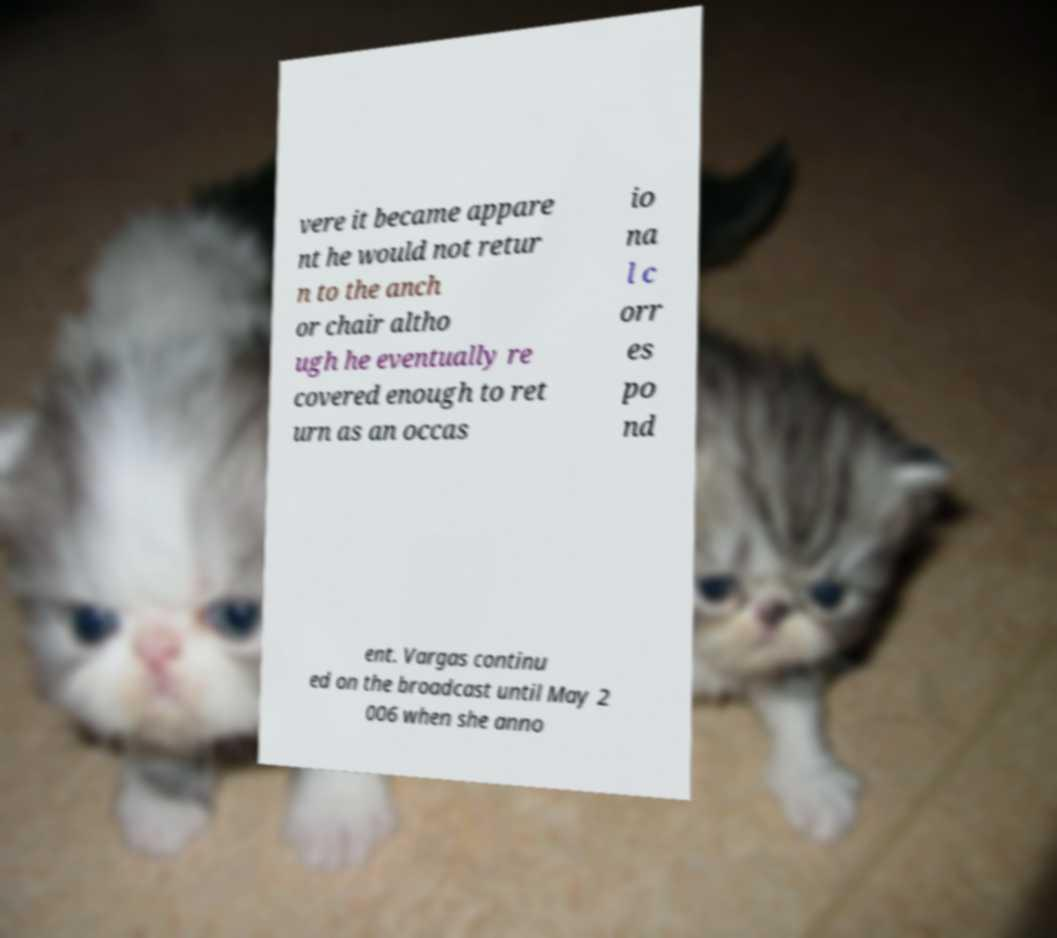Could you extract and type out the text from this image? vere it became appare nt he would not retur n to the anch or chair altho ugh he eventually re covered enough to ret urn as an occas io na l c orr es po nd ent. Vargas continu ed on the broadcast until May 2 006 when she anno 